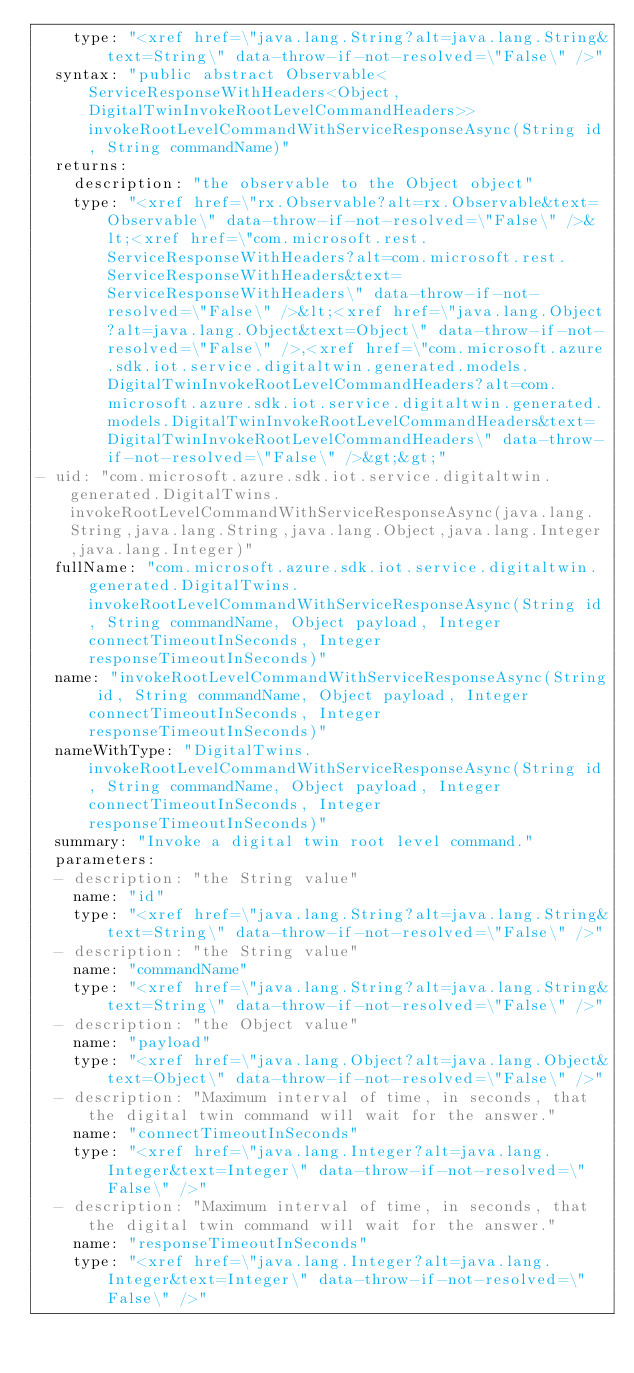Convert code to text. <code><loc_0><loc_0><loc_500><loc_500><_YAML_>    type: "<xref href=\"java.lang.String?alt=java.lang.String&text=String\" data-throw-if-not-resolved=\"False\" />"
  syntax: "public abstract Observable<ServiceResponseWithHeaders<Object,DigitalTwinInvokeRootLevelCommandHeaders>> invokeRootLevelCommandWithServiceResponseAsync(String id, String commandName)"
  returns:
    description: "the observable to the Object object"
    type: "<xref href=\"rx.Observable?alt=rx.Observable&text=Observable\" data-throw-if-not-resolved=\"False\" />&lt;<xref href=\"com.microsoft.rest.ServiceResponseWithHeaders?alt=com.microsoft.rest.ServiceResponseWithHeaders&text=ServiceResponseWithHeaders\" data-throw-if-not-resolved=\"False\" />&lt;<xref href=\"java.lang.Object?alt=java.lang.Object&text=Object\" data-throw-if-not-resolved=\"False\" />,<xref href=\"com.microsoft.azure.sdk.iot.service.digitaltwin.generated.models.DigitalTwinInvokeRootLevelCommandHeaders?alt=com.microsoft.azure.sdk.iot.service.digitaltwin.generated.models.DigitalTwinInvokeRootLevelCommandHeaders&text=DigitalTwinInvokeRootLevelCommandHeaders\" data-throw-if-not-resolved=\"False\" />&gt;&gt;"
- uid: "com.microsoft.azure.sdk.iot.service.digitaltwin.generated.DigitalTwins.invokeRootLevelCommandWithServiceResponseAsync(java.lang.String,java.lang.String,java.lang.Object,java.lang.Integer,java.lang.Integer)"
  fullName: "com.microsoft.azure.sdk.iot.service.digitaltwin.generated.DigitalTwins.invokeRootLevelCommandWithServiceResponseAsync(String id, String commandName, Object payload, Integer connectTimeoutInSeconds, Integer responseTimeoutInSeconds)"
  name: "invokeRootLevelCommandWithServiceResponseAsync(String id, String commandName, Object payload, Integer connectTimeoutInSeconds, Integer responseTimeoutInSeconds)"
  nameWithType: "DigitalTwins.invokeRootLevelCommandWithServiceResponseAsync(String id, String commandName, Object payload, Integer connectTimeoutInSeconds, Integer responseTimeoutInSeconds)"
  summary: "Invoke a digital twin root level command."
  parameters:
  - description: "the String value"
    name: "id"
    type: "<xref href=\"java.lang.String?alt=java.lang.String&text=String\" data-throw-if-not-resolved=\"False\" />"
  - description: "the String value"
    name: "commandName"
    type: "<xref href=\"java.lang.String?alt=java.lang.String&text=String\" data-throw-if-not-resolved=\"False\" />"
  - description: "the Object value"
    name: "payload"
    type: "<xref href=\"java.lang.Object?alt=java.lang.Object&text=Object\" data-throw-if-not-resolved=\"False\" />"
  - description: "Maximum interval of time, in seconds, that the digital twin command will wait for the answer."
    name: "connectTimeoutInSeconds"
    type: "<xref href=\"java.lang.Integer?alt=java.lang.Integer&text=Integer\" data-throw-if-not-resolved=\"False\" />"
  - description: "Maximum interval of time, in seconds, that the digital twin command will wait for the answer."
    name: "responseTimeoutInSeconds"
    type: "<xref href=\"java.lang.Integer?alt=java.lang.Integer&text=Integer\" data-throw-if-not-resolved=\"False\" />"</code> 